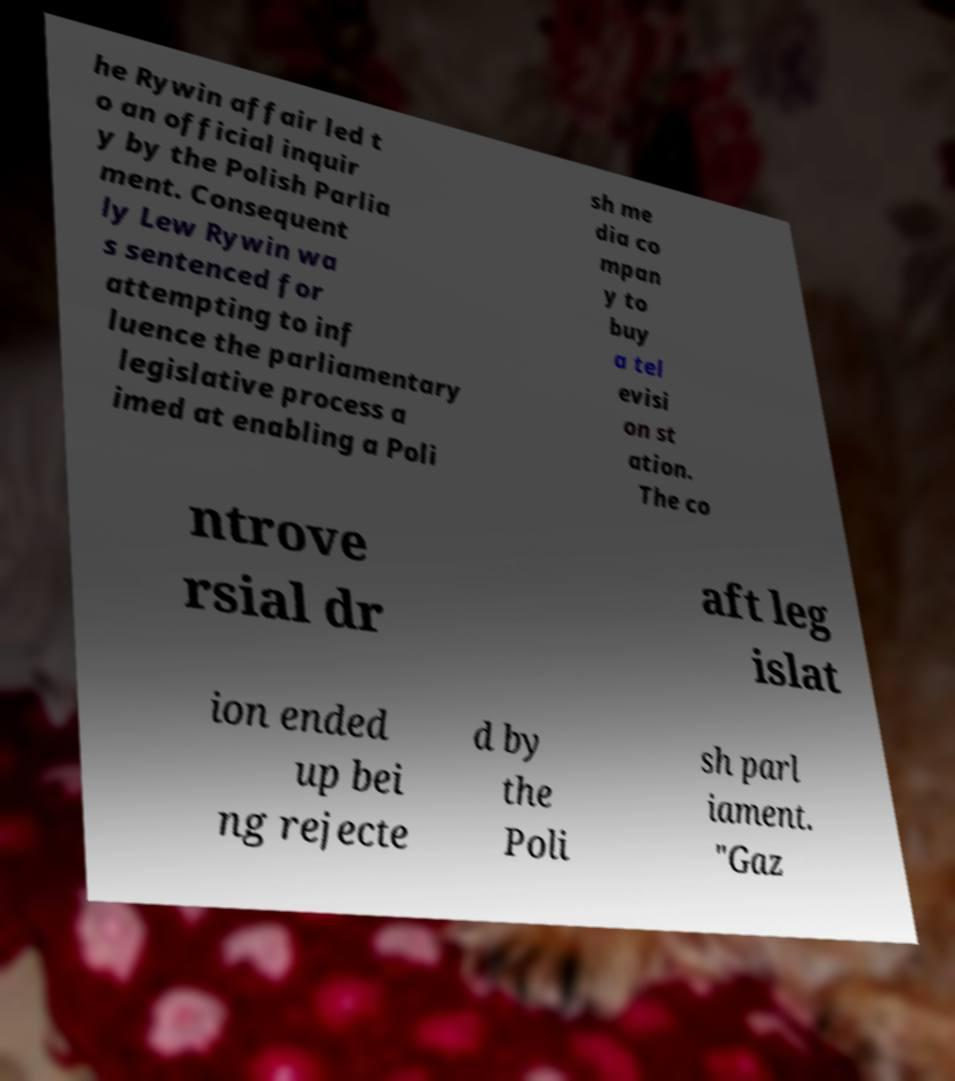Can you read and provide the text displayed in the image?This photo seems to have some interesting text. Can you extract and type it out for me? he Rywin affair led t o an official inquir y by the Polish Parlia ment. Consequent ly Lew Rywin wa s sentenced for attempting to inf luence the parliamentary legislative process a imed at enabling a Poli sh me dia co mpan y to buy a tel evisi on st ation. The co ntrove rsial dr aft leg islat ion ended up bei ng rejecte d by the Poli sh parl iament. "Gaz 